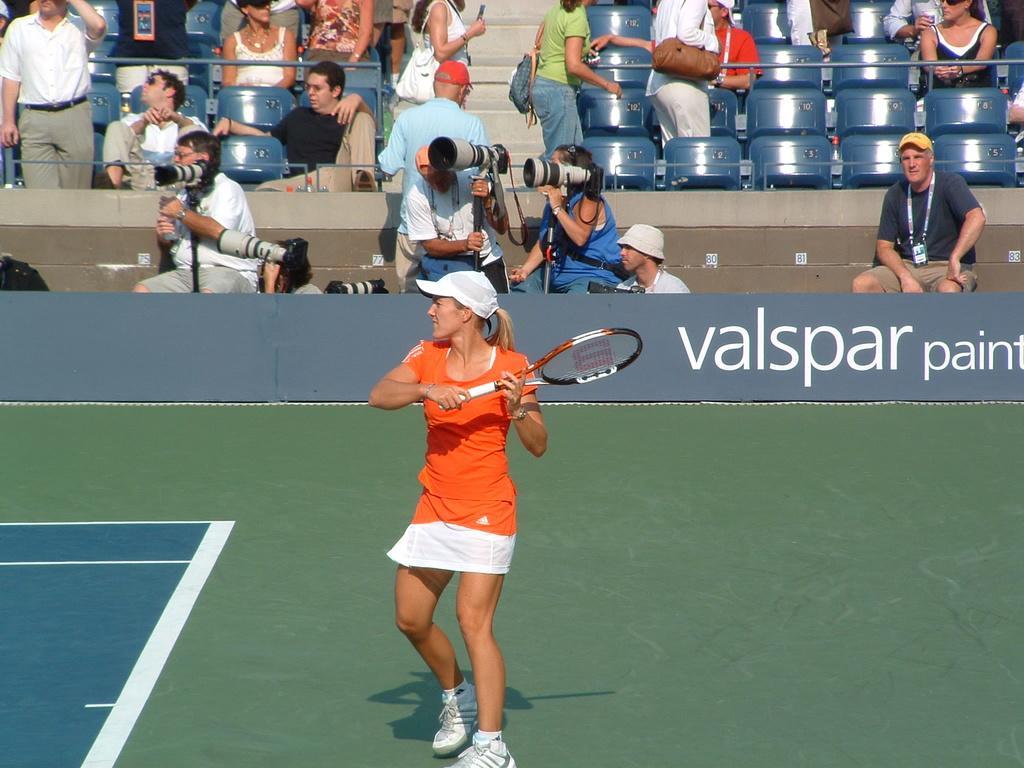Describe this image in one or two sentences. There is a group of people. They are sitting on a chairs and some persons are standing. They are wearing a bag. In the center we have a woman. She is wearing a cap and she is holding a bat. In background we can see three persons are wearing a id card and cap. 